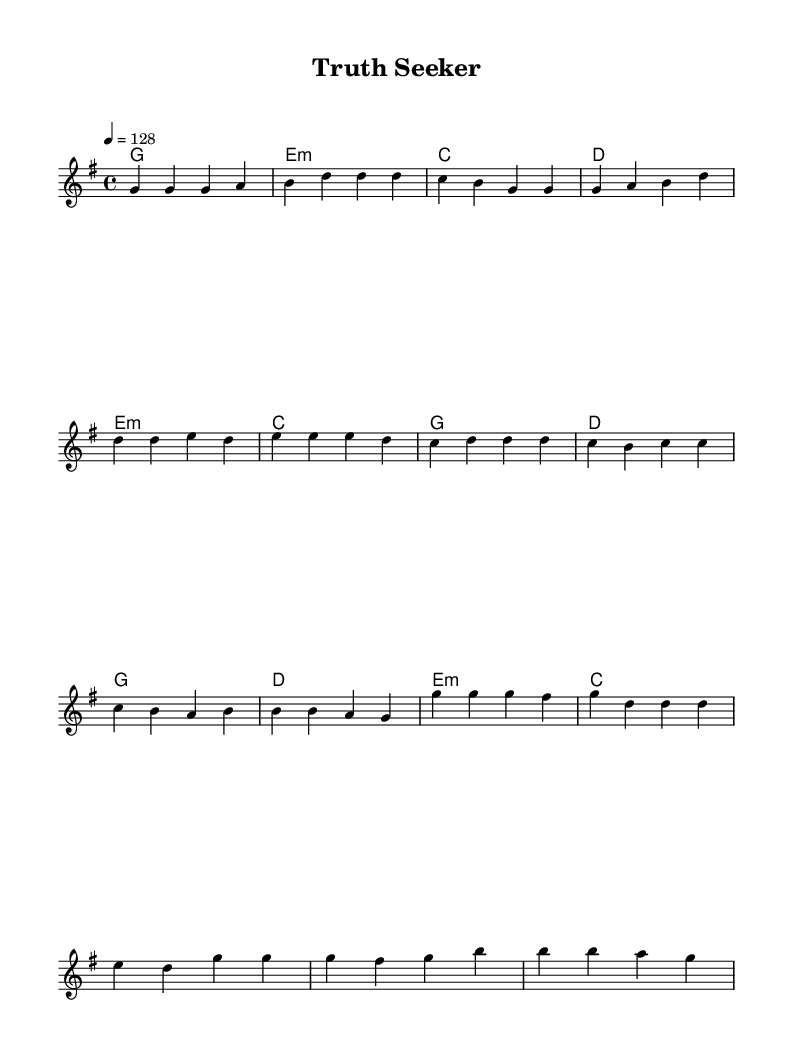What is the key signature of this music? The key signature is G major, which has one sharp (F#). This is indicated at the beginning of the sheet music with the key signature placed on the staff.
Answer: G major What is the time signature of this music? The time signature shown at the beginning is 4/4, meaning each measure contains four beats, and the quarter note gets one beat. This is indicated in the notation at the start of the piece.
Answer: 4/4 What is the tempo of the piece? The tempo is marked at 128 beats per minute, stated at the beginning of the score with the tempo marking "4 = 128." This indicates the speed of the music.
Answer: 128 How many sections are in the song? The song is divided into three distinct sections: Verse, Pre-Chorus, and Chorus. Each section is clearly labeled in the melody’s structure, indicating the different parts of the composition.
Answer: 3 What is the first chord in the piece? The first chord indicated in the harmonies is G major, as shown in the chord changes at the beginning of the piece. This will guide the harmony throughout the first measure.
Answer: G Which section contains the highest note? The highest note appears in the Chorus section where the melody reaches a g' (indicating it is the octave above g). The structure of the melody and heights of the notes throughout the sections lead to the identification of this highest pitch.
Answer: g' What is the length of each measure? Each measure contains four beats, as denoted by the 4/4 time signature. Therefore, the length of each measure is consistent, making it easy for musicians to follow the rhythm throughout the piece.
Answer: 4 beats 